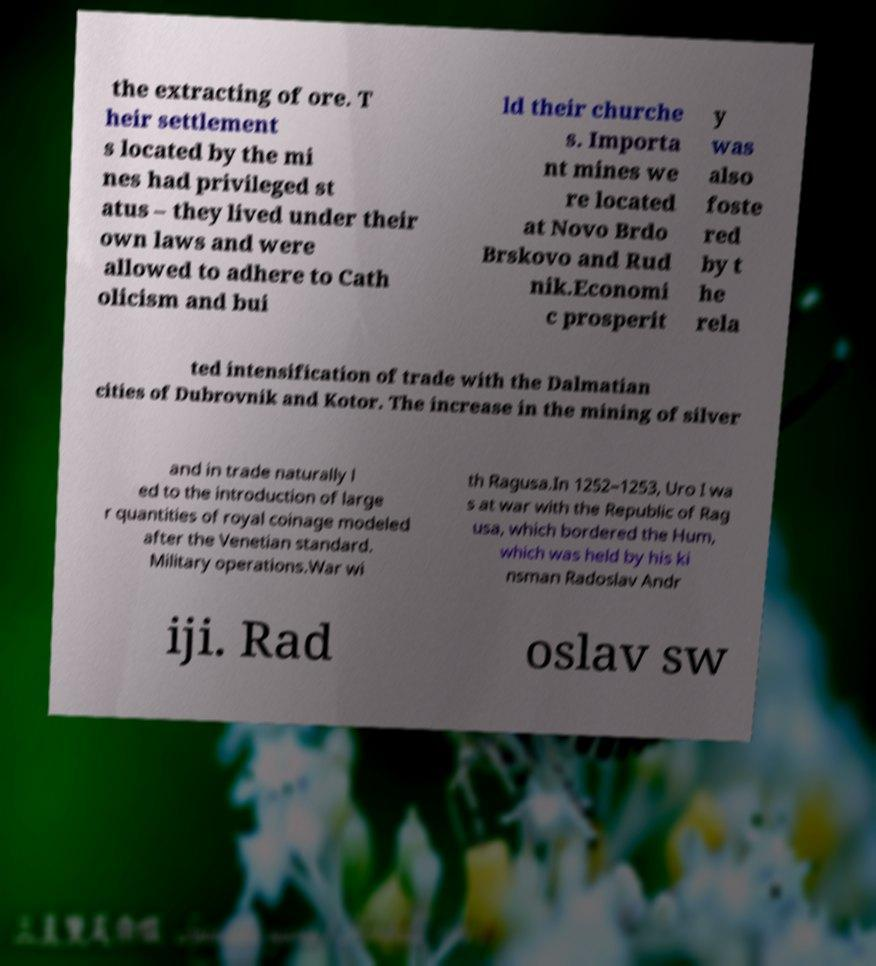Can you read and provide the text displayed in the image?This photo seems to have some interesting text. Can you extract and type it out for me? the extracting of ore. T heir settlement s located by the mi nes had privileged st atus – they lived under their own laws and were allowed to adhere to Cath olicism and bui ld their churche s. Importa nt mines we re located at Novo Brdo Brskovo and Rud nik.Economi c prosperit y was also foste red by t he rela ted intensification of trade with the Dalmatian cities of Dubrovnik and Kotor. The increase in the mining of silver and in trade naturally l ed to the introduction of large r quantities of royal coinage modeled after the Venetian standard. Military operations.War wi th Ragusa.In 1252–1253, Uro I wa s at war with the Republic of Rag usa, which bordered the Hum, which was held by his ki nsman Radoslav Andr iji. Rad oslav sw 